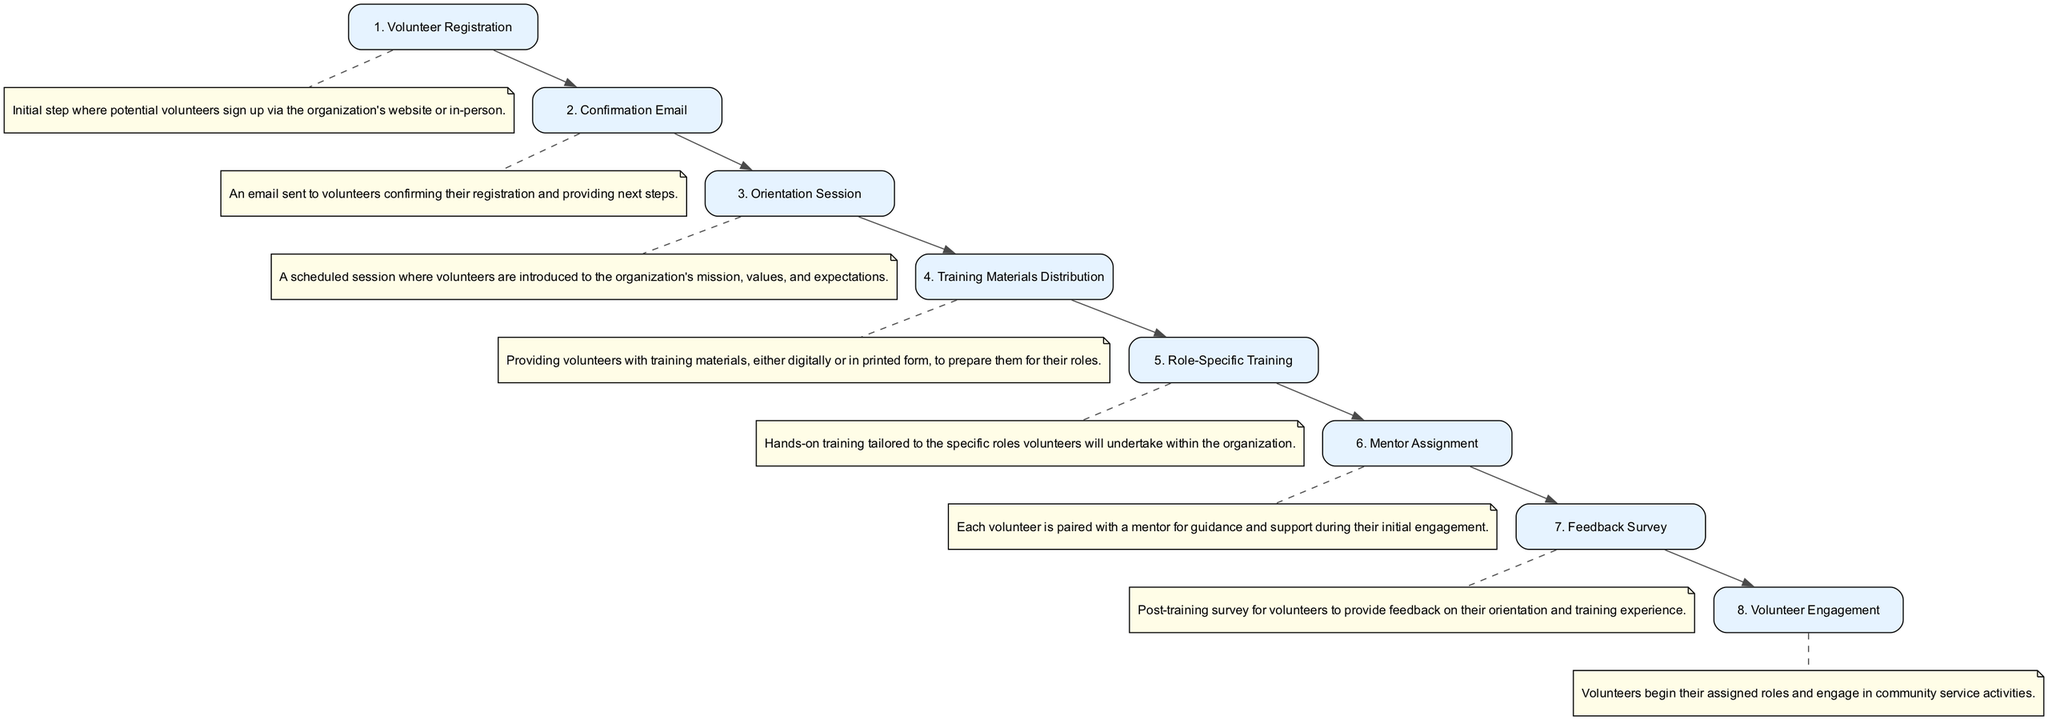What is the first step in the sequence? The first step listed in the sequence is "Volunteer Registration", which indicates the initial action taken by potential volunteers.
Answer: Volunteer Registration How many steps are included in the diagram? The diagram contains eight steps that represent the sequence of volunteer orientation and training activities.
Answer: Eight What follows the Confirmation Email step? After the Confirmation Email, the next step in the sequence is the "Orientation Session", marking the beginning of the training process.
Answer: Orientation Session Which step involves hands-on training? The "Role-Specific Training" step involves hands-on training tailored to the specific roles volunteers will undertake within the organization.
Answer: Role-Specific Training How many feedback surveys are collected after the training? There is one feedback survey collected after the training, specifically at the "Feedback Survey" step to assess the volunteers' experience.
Answer: One What is the purpose of the Mentor Assignment step? The Mentor Assignment step provides guidance and support for volunteers by pairing them with a mentor during their initial engagement.
Answer: Guidance and support What is the last step in the training sequence? The last step in the training sequence is "Volunteer Engagement", where volunteers start their assigned roles and engage in community service activities.
Answer: Volunteer Engagement What do volunteers receive before the Role-Specific Training? Volunteers receive "Training Materials Distribution" prior to the Role-Specific Training, ensuring they have the necessary resources to prepare for their roles.
Answer: Training Materials Distribution What is the connection between the Orientation Session and the Training Materials Distribution? The Orientation Session is directly followed by the Training Materials Distribution, indicating that after being oriented, volunteers receive training materials.
Answer: Directly followed 